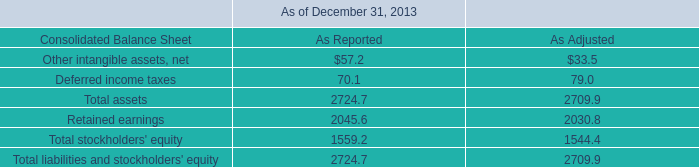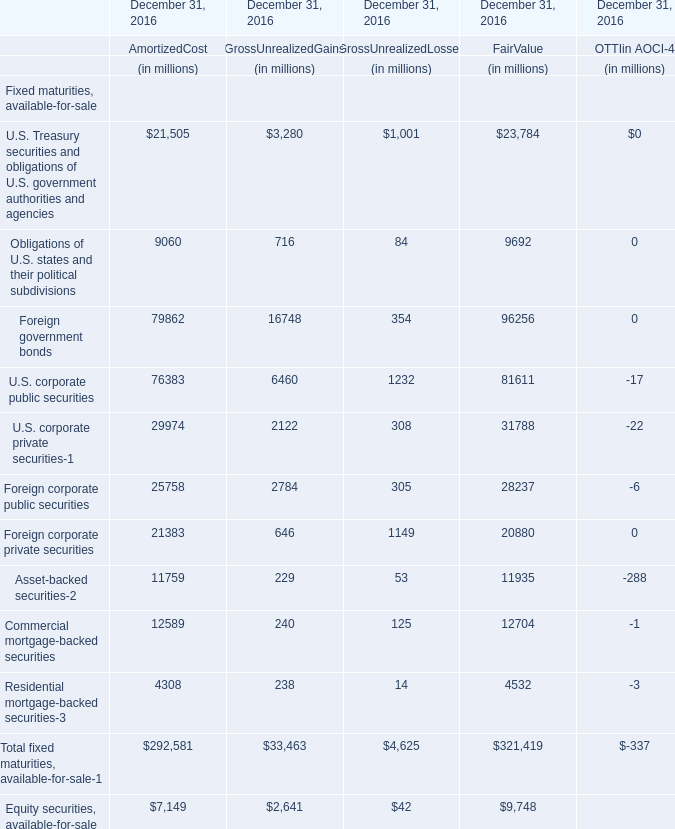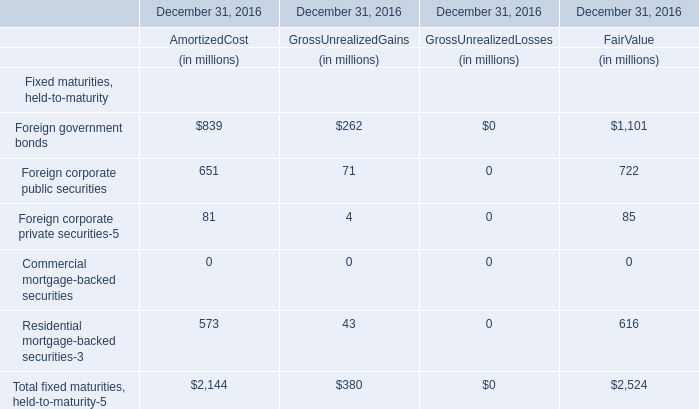What's the sum of all Foreign government bonds that are positive in 2016 ? 
Computations: ((839 + 262) + 1101)
Answer: 2202.0. 